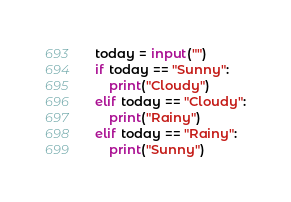<code> <loc_0><loc_0><loc_500><loc_500><_Python_>today = input("")
if today == "Sunny":
    print("Cloudy")
elif today == "Cloudy":
    print("Rainy")
elif today == "Rainy":
    print("Sunny")</code> 